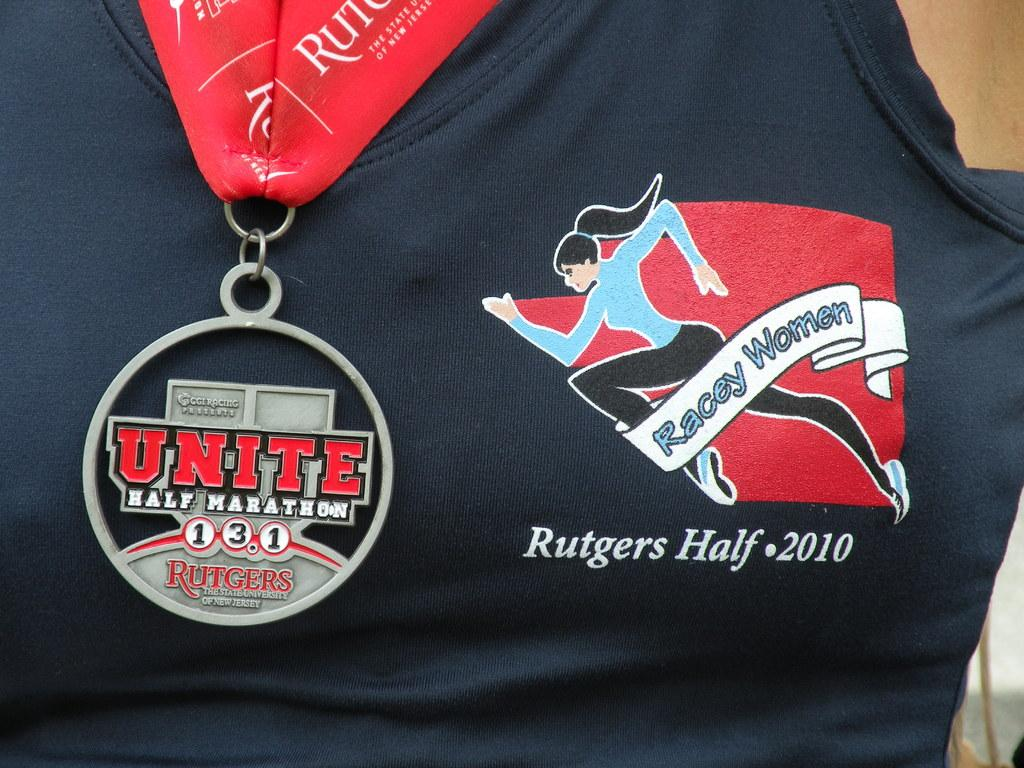<image>
Relay a brief, clear account of the picture shown. A women wears a medal for Unite Half Marathon. 